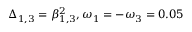Convert formula to latex. <formula><loc_0><loc_0><loc_500><loc_500>\Delta _ { 1 , 3 } = \beta _ { 1 , 3 } ^ { 2 } , \omega _ { 1 } = - \omega _ { 3 } = 0 . 0 5</formula> 